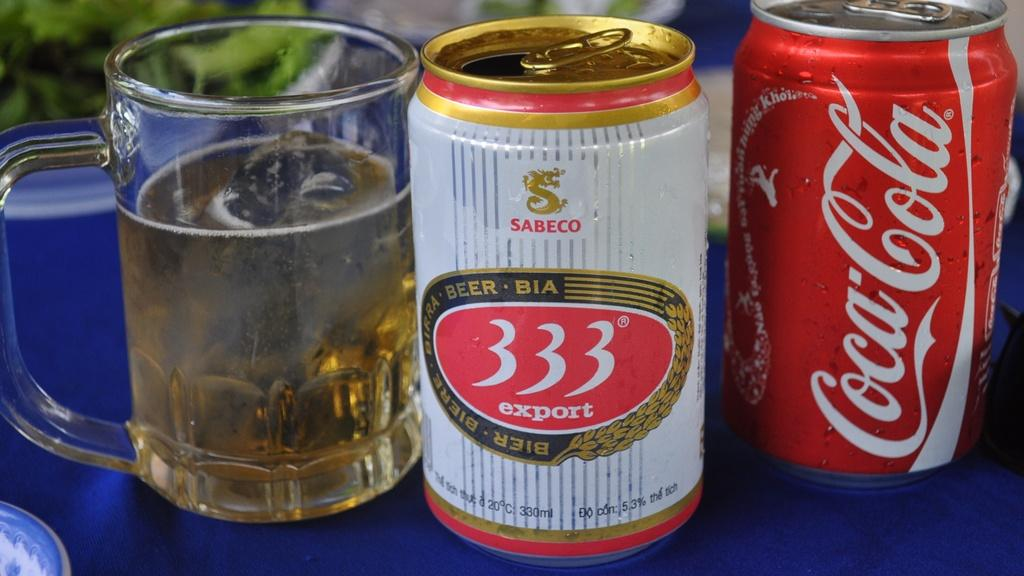<image>
Share a concise interpretation of the image provided. the numbers 333 are on the can of soda 